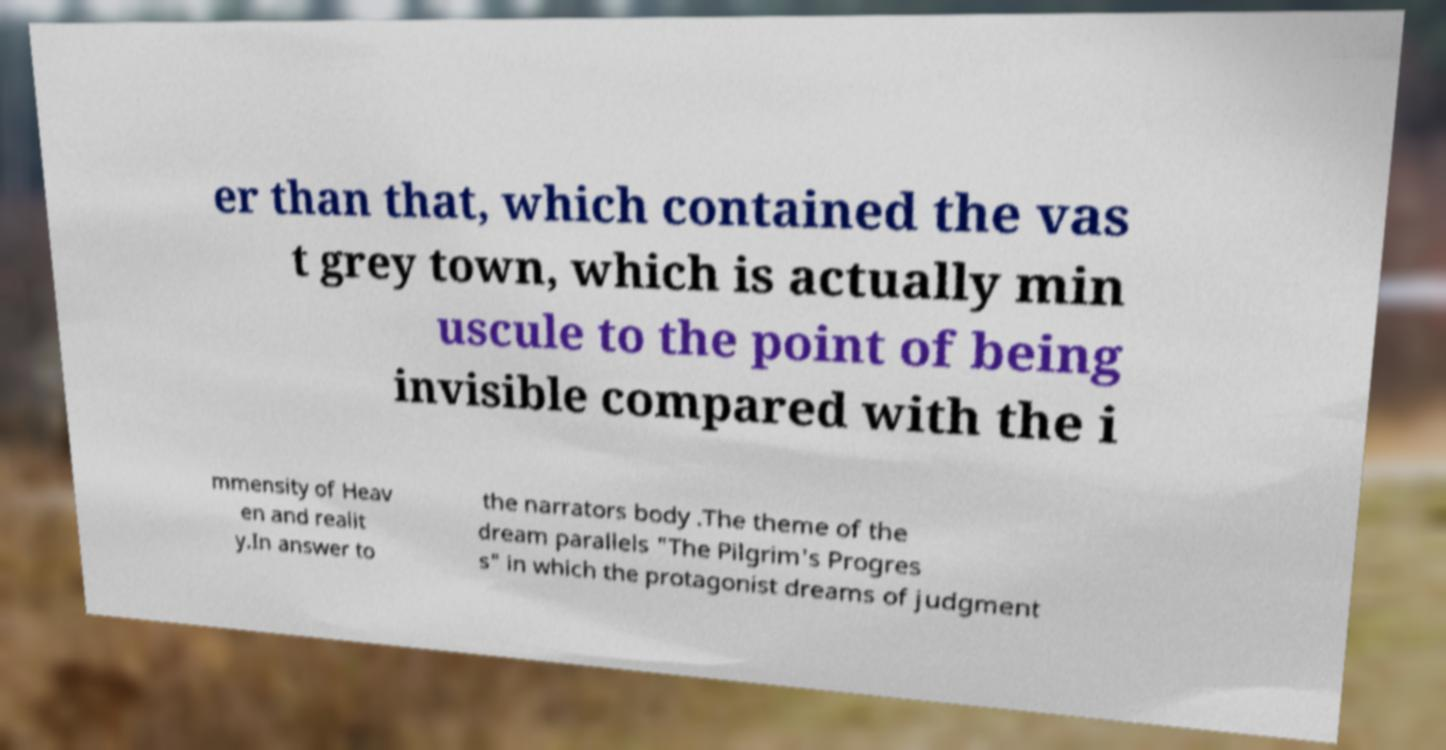Can you accurately transcribe the text from the provided image for me? er than that, which contained the vas t grey town, which is actually min uscule to the point of being invisible compared with the i mmensity of Heav en and realit y.In answer to the narrators body .The theme of the dream parallels "The Pilgrim's Progres s" in which the protagonist dreams of judgment 